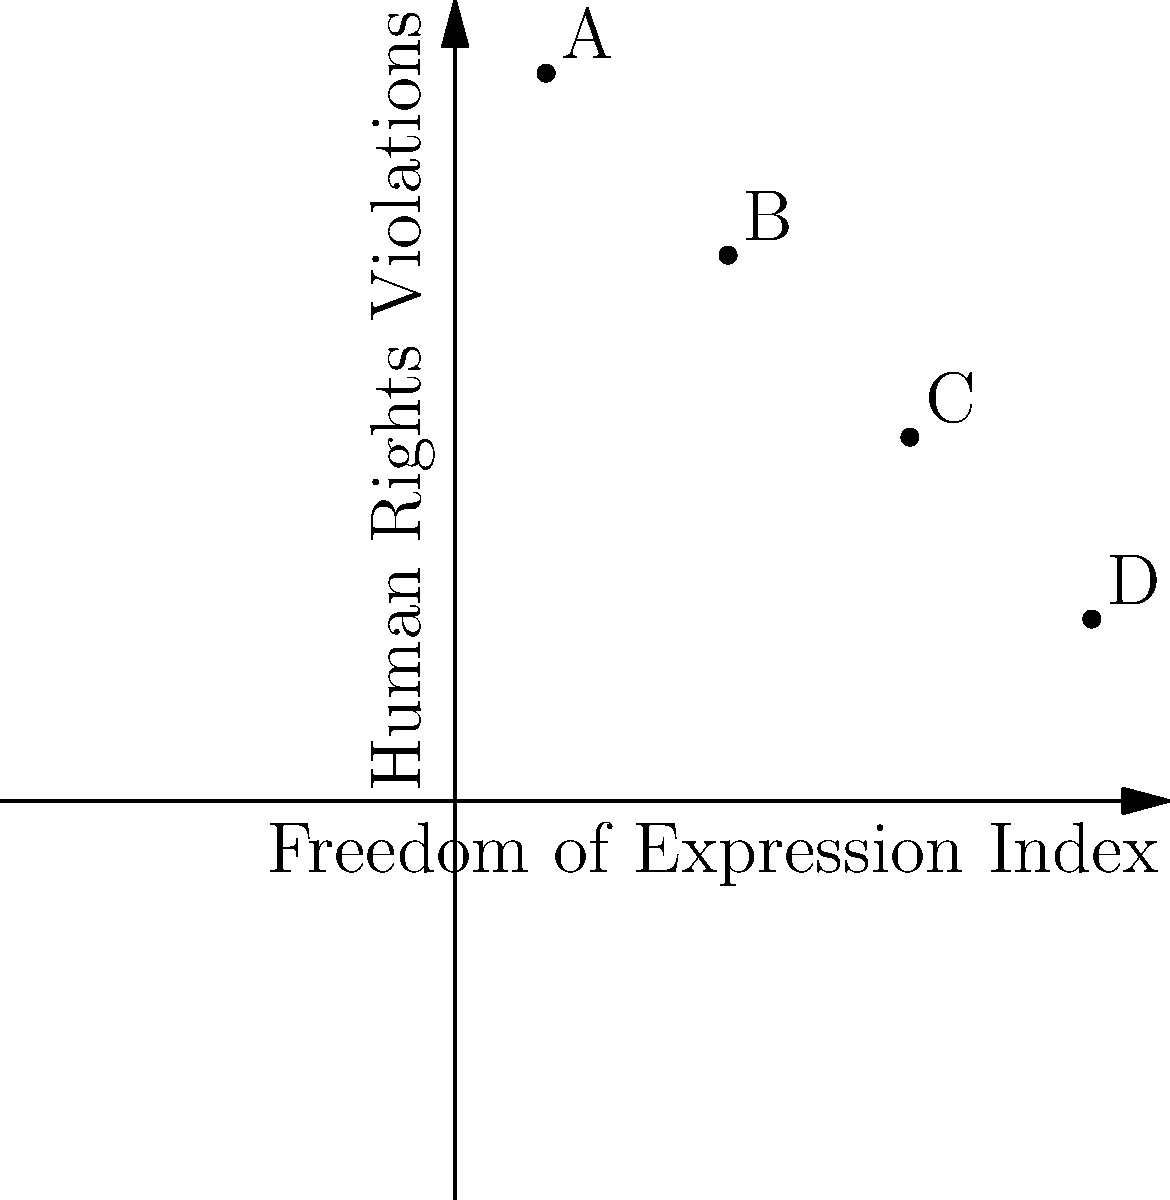The graph shows the relationship between the Freedom of Expression Index (x-axis) and the number of Human Rights Violations (y-axis) for four countries A, B, C, and D. What is the slope of the line connecting countries A and D, and what does this slope represent in the context of human rights? To find the slope of the line connecting countries A and D:

1. Identify the coordinates:
   Country A: (1, 8)
   Country D: (7, 2)

2. Use the slope formula: $m = \frac{y_2 - y_1}{x_2 - x_1}$

3. Plug in the values:
   $m = \frac{2 - 8}{7 - 1} = \frac{-6}{6} = -1$

4. Interpret the slope:
   The slope is -1, which means for every 1-point increase in the Freedom of Expression Index, there is a decrease of 1 in the number of Human Rights Violations.

5. Context interpretation:
   This negative slope indicates an inverse relationship between Freedom of Expression and Human Rights Violations. As countries improve their Freedom of Expression, they tend to experience fewer Human Rights Violations.
Answer: -1; inverse relationship between Freedom of Expression and Human Rights Violations 